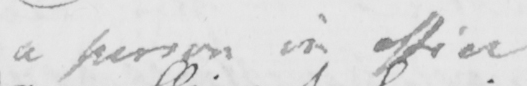Please provide the text content of this handwritten line. a person in office 